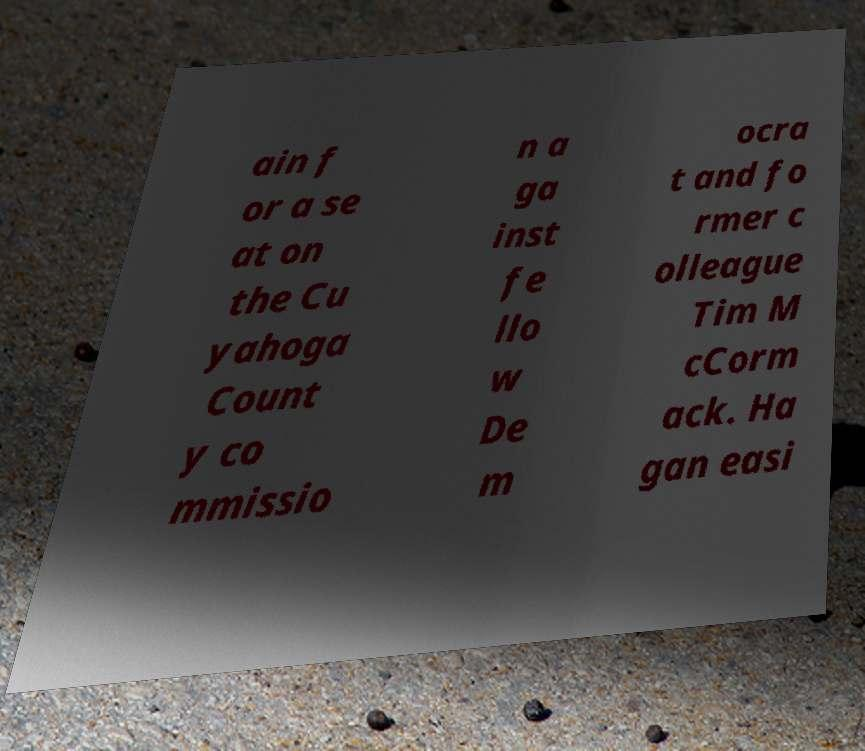I need the written content from this picture converted into text. Can you do that? ain f or a se at on the Cu yahoga Count y co mmissio n a ga inst fe llo w De m ocra t and fo rmer c olleague Tim M cCorm ack. Ha gan easi 